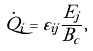Convert formula to latex. <formula><loc_0><loc_0><loc_500><loc_500>\dot { Q } _ { i } = \varepsilon _ { i j } \frac { E _ { j } } { B _ { c } } ,</formula> 